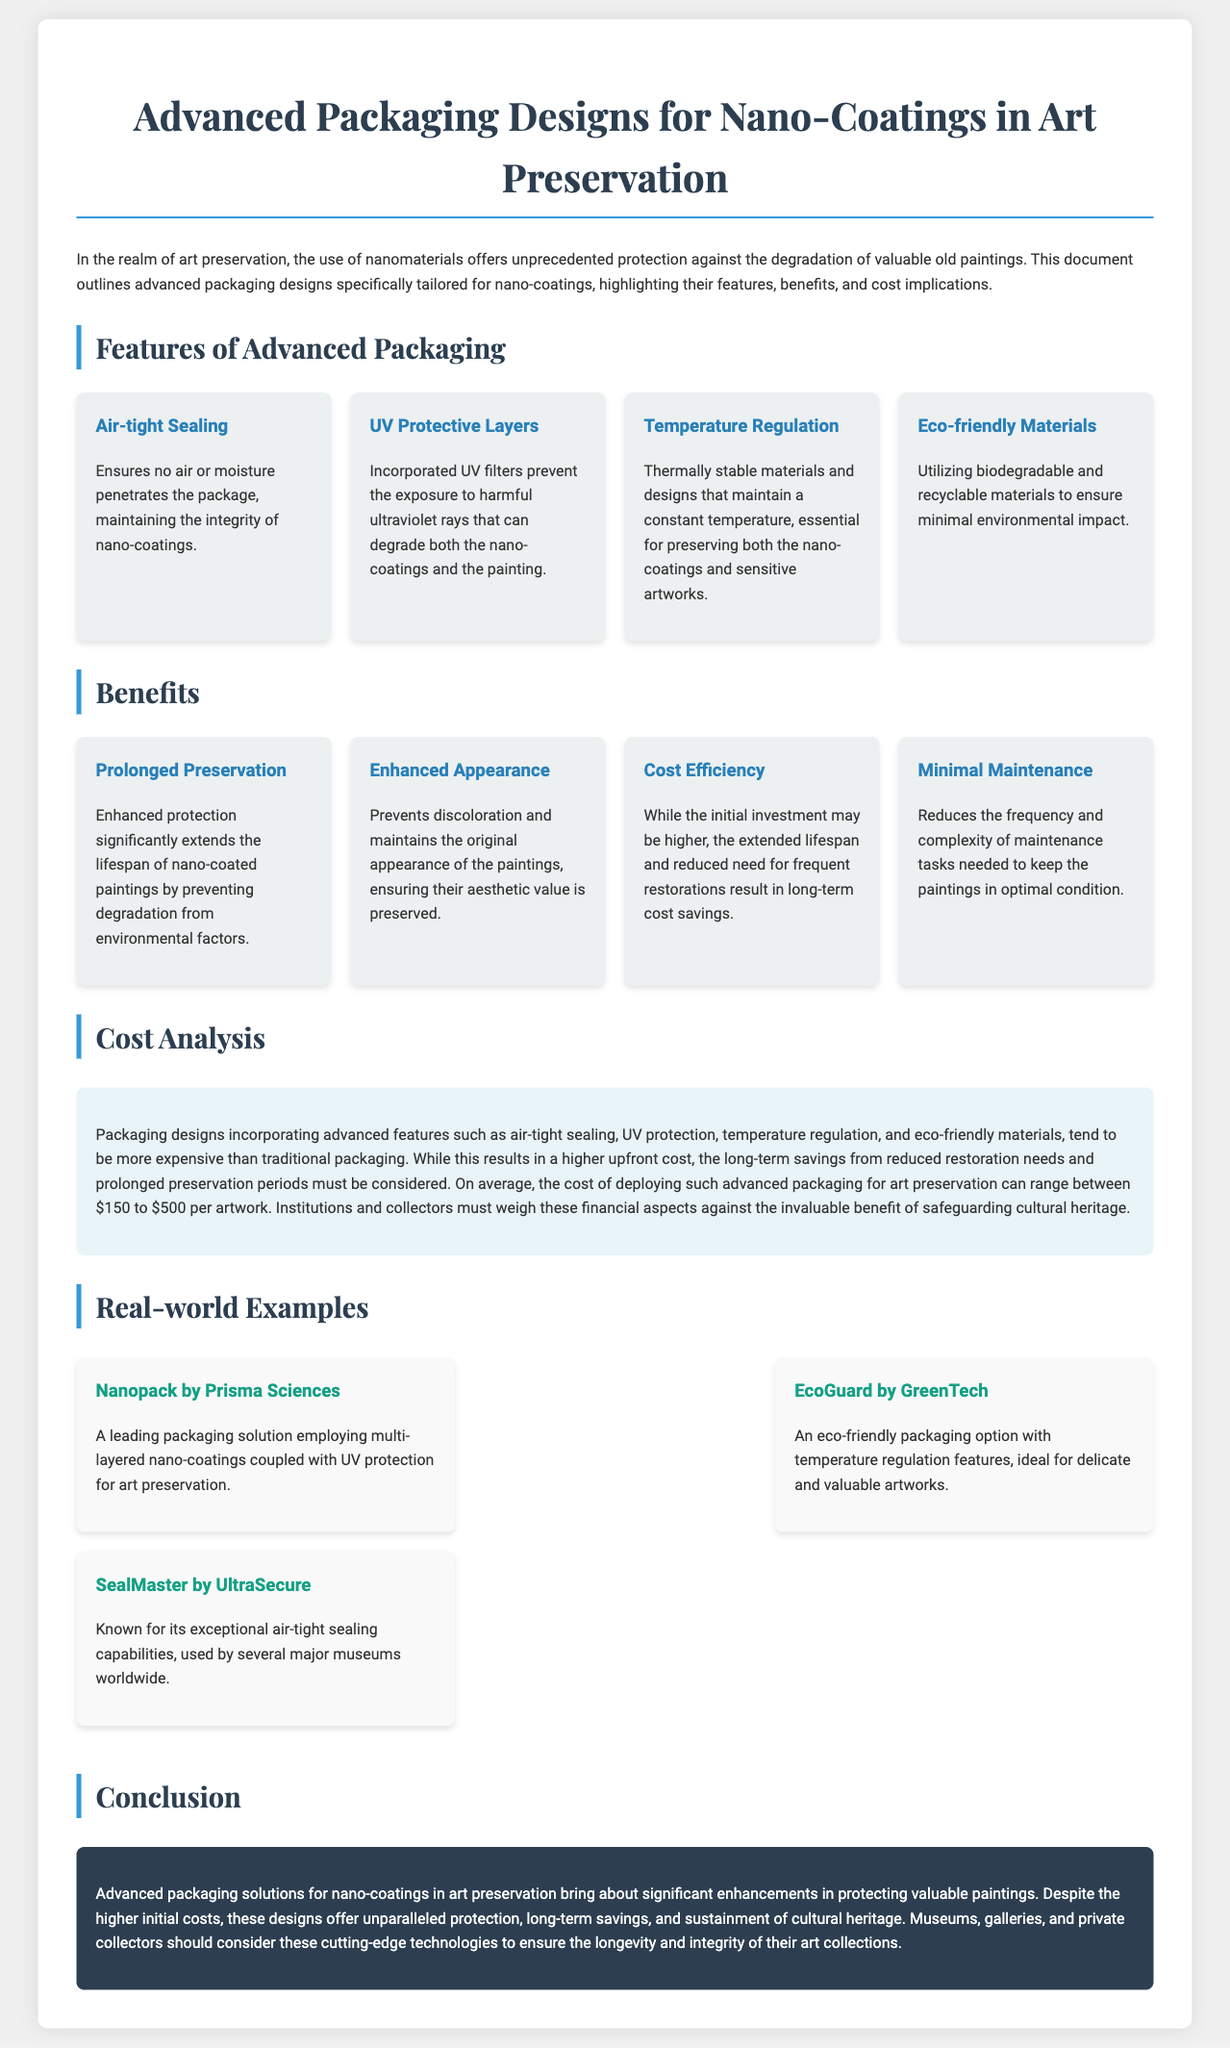What is the title of the document? The title is stated in the heading at the top of the document.
Answer: Advanced Packaging Designs for Nano-Coatings in Art Preservation How many features are listed under Advanced Packaging? The document lists four distinct features in the feature grid.
Answer: Four What is one of the benefits of using advanced packaging? The benefits are outlined in the benefit grid, and one is highlighted for prolonged preservation.
Answer: Prolonged Preservation What is the average cost range for advanced packaging deployment? The cost analysis section specifies the average cost range for packaging per artwork.
Answer: $150 to $500 What material type is emphasized for eco-friendliness? The document specifically mentions the use of biodegradable and recyclable materials.
Answer: Eco-friendly Materials What company offers a nanopack solution? The real-world examples provide a specific company offering the mentioned solution.
Answer: Prisma Sciences How does advanced packaging affect long-term costs? The document notes that despite the higher initial investment, long-term cost savings are achieved.
Answer: Cost Efficiency What kind of protection does the UV Protective Layer offer? The UV Protective Layer serves to prevent exposure to harmful ultraviolet rays.
Answer: UV protection Which feature is essential for maintaining the artworks' condition? Temperature regulation is mentioned as crucial for preserving artworks.
Answer: Temperature Regulation 